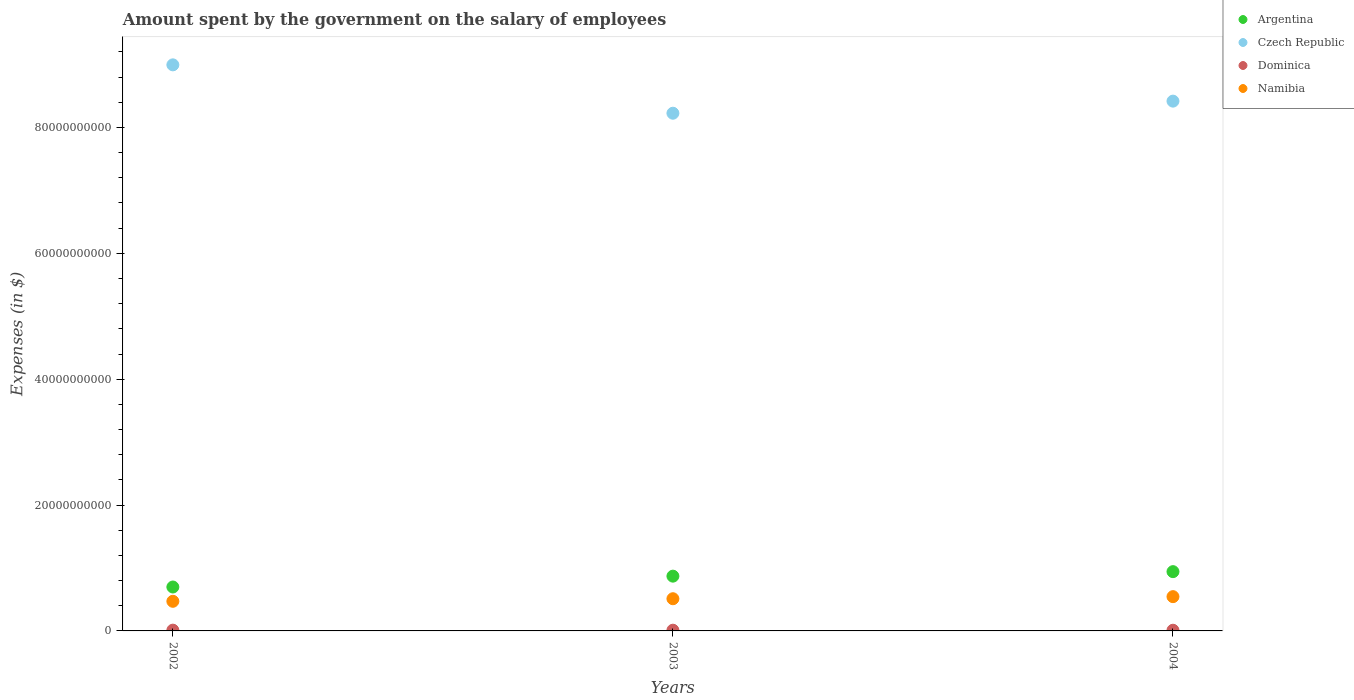How many different coloured dotlines are there?
Offer a terse response. 4. Is the number of dotlines equal to the number of legend labels?
Give a very brief answer. Yes. What is the amount spent on the salary of employees by the government in Namibia in 2002?
Make the answer very short. 4.71e+09. Across all years, what is the maximum amount spent on the salary of employees by the government in Czech Republic?
Your answer should be very brief. 9.00e+1. Across all years, what is the minimum amount spent on the salary of employees by the government in Namibia?
Offer a terse response. 4.71e+09. What is the total amount spent on the salary of employees by the government in Dominica in the graph?
Your answer should be very brief. 3.49e+08. What is the difference between the amount spent on the salary of employees by the government in Argentina in 2002 and that in 2003?
Your answer should be very brief. -1.72e+09. What is the difference between the amount spent on the salary of employees by the government in Czech Republic in 2002 and the amount spent on the salary of employees by the government in Namibia in 2003?
Your answer should be very brief. 8.48e+1. What is the average amount spent on the salary of employees by the government in Argentina per year?
Provide a succinct answer. 8.37e+09. In the year 2004, what is the difference between the amount spent on the salary of employees by the government in Dominica and amount spent on the salary of employees by the government in Czech Republic?
Offer a very short reply. -8.41e+1. What is the ratio of the amount spent on the salary of employees by the government in Czech Republic in 2002 to that in 2004?
Offer a terse response. 1.07. Is the difference between the amount spent on the salary of employees by the government in Dominica in 2002 and 2004 greater than the difference between the amount spent on the salary of employees by the government in Czech Republic in 2002 and 2004?
Provide a short and direct response. No. What is the difference between the highest and the second highest amount spent on the salary of employees by the government in Dominica?
Offer a very short reply. 8.30e+06. What is the difference between the highest and the lowest amount spent on the salary of employees by the government in Dominica?
Your response must be concise. 1.46e+07. In how many years, is the amount spent on the salary of employees by the government in Namibia greater than the average amount spent on the salary of employees by the government in Namibia taken over all years?
Your answer should be compact. 2. Is the sum of the amount spent on the salary of employees by the government in Czech Republic in 2002 and 2004 greater than the maximum amount spent on the salary of employees by the government in Argentina across all years?
Your answer should be very brief. Yes. Is the amount spent on the salary of employees by the government in Dominica strictly greater than the amount spent on the salary of employees by the government in Czech Republic over the years?
Your response must be concise. No. What is the difference between two consecutive major ticks on the Y-axis?
Give a very brief answer. 2.00e+1. How many legend labels are there?
Your answer should be compact. 4. What is the title of the graph?
Your answer should be very brief. Amount spent by the government on the salary of employees. What is the label or title of the Y-axis?
Offer a terse response. Expenses (in $). What is the Expenses (in $) in Argentina in 2002?
Offer a very short reply. 6.98e+09. What is the Expenses (in $) of Czech Republic in 2002?
Provide a succinct answer. 9.00e+1. What is the Expenses (in $) of Dominica in 2002?
Keep it short and to the point. 1.24e+08. What is the Expenses (in $) of Namibia in 2002?
Provide a short and direct response. 4.71e+09. What is the Expenses (in $) of Argentina in 2003?
Offer a terse response. 8.70e+09. What is the Expenses (in $) in Czech Republic in 2003?
Ensure brevity in your answer.  8.23e+1. What is the Expenses (in $) in Dominica in 2003?
Offer a terse response. 1.16e+08. What is the Expenses (in $) of Namibia in 2003?
Offer a terse response. 5.12e+09. What is the Expenses (in $) in Argentina in 2004?
Offer a terse response. 9.42e+09. What is the Expenses (in $) in Czech Republic in 2004?
Provide a short and direct response. 8.42e+1. What is the Expenses (in $) of Dominica in 2004?
Provide a succinct answer. 1.09e+08. What is the Expenses (in $) in Namibia in 2004?
Provide a short and direct response. 5.45e+09. Across all years, what is the maximum Expenses (in $) of Argentina?
Ensure brevity in your answer.  9.42e+09. Across all years, what is the maximum Expenses (in $) in Czech Republic?
Provide a short and direct response. 9.00e+1. Across all years, what is the maximum Expenses (in $) in Dominica?
Provide a short and direct response. 1.24e+08. Across all years, what is the maximum Expenses (in $) in Namibia?
Provide a succinct answer. 5.45e+09. Across all years, what is the minimum Expenses (in $) of Argentina?
Offer a very short reply. 6.98e+09. Across all years, what is the minimum Expenses (in $) of Czech Republic?
Make the answer very short. 8.23e+1. Across all years, what is the minimum Expenses (in $) in Dominica?
Give a very brief answer. 1.09e+08. Across all years, what is the minimum Expenses (in $) in Namibia?
Provide a succinct answer. 4.71e+09. What is the total Expenses (in $) of Argentina in the graph?
Give a very brief answer. 2.51e+1. What is the total Expenses (in $) of Czech Republic in the graph?
Ensure brevity in your answer.  2.56e+11. What is the total Expenses (in $) of Dominica in the graph?
Offer a terse response. 3.49e+08. What is the total Expenses (in $) of Namibia in the graph?
Provide a short and direct response. 1.53e+1. What is the difference between the Expenses (in $) of Argentina in 2002 and that in 2003?
Provide a succinct answer. -1.72e+09. What is the difference between the Expenses (in $) of Czech Republic in 2002 and that in 2003?
Offer a very short reply. 7.69e+09. What is the difference between the Expenses (in $) of Dominica in 2002 and that in 2003?
Make the answer very short. 8.30e+06. What is the difference between the Expenses (in $) of Namibia in 2002 and that in 2003?
Offer a terse response. -4.10e+08. What is the difference between the Expenses (in $) of Argentina in 2002 and that in 2004?
Keep it short and to the point. -2.44e+09. What is the difference between the Expenses (in $) of Czech Republic in 2002 and that in 2004?
Your answer should be very brief. 5.77e+09. What is the difference between the Expenses (in $) in Dominica in 2002 and that in 2004?
Ensure brevity in your answer.  1.46e+07. What is the difference between the Expenses (in $) in Namibia in 2002 and that in 2004?
Make the answer very short. -7.39e+08. What is the difference between the Expenses (in $) of Argentina in 2003 and that in 2004?
Give a very brief answer. -7.17e+08. What is the difference between the Expenses (in $) in Czech Republic in 2003 and that in 2004?
Offer a terse response. -1.92e+09. What is the difference between the Expenses (in $) in Dominica in 2003 and that in 2004?
Give a very brief answer. 6.30e+06. What is the difference between the Expenses (in $) of Namibia in 2003 and that in 2004?
Your answer should be very brief. -3.29e+08. What is the difference between the Expenses (in $) of Argentina in 2002 and the Expenses (in $) of Czech Republic in 2003?
Your answer should be very brief. -7.53e+1. What is the difference between the Expenses (in $) of Argentina in 2002 and the Expenses (in $) of Dominica in 2003?
Your answer should be very brief. 6.86e+09. What is the difference between the Expenses (in $) in Argentina in 2002 and the Expenses (in $) in Namibia in 2003?
Offer a very short reply. 1.86e+09. What is the difference between the Expenses (in $) in Czech Republic in 2002 and the Expenses (in $) in Dominica in 2003?
Ensure brevity in your answer.  8.98e+1. What is the difference between the Expenses (in $) of Czech Republic in 2002 and the Expenses (in $) of Namibia in 2003?
Your answer should be compact. 8.48e+1. What is the difference between the Expenses (in $) in Dominica in 2002 and the Expenses (in $) in Namibia in 2003?
Make the answer very short. -4.99e+09. What is the difference between the Expenses (in $) in Argentina in 2002 and the Expenses (in $) in Czech Republic in 2004?
Give a very brief answer. -7.72e+1. What is the difference between the Expenses (in $) in Argentina in 2002 and the Expenses (in $) in Dominica in 2004?
Your response must be concise. 6.87e+09. What is the difference between the Expenses (in $) of Argentina in 2002 and the Expenses (in $) of Namibia in 2004?
Your response must be concise. 1.53e+09. What is the difference between the Expenses (in $) in Czech Republic in 2002 and the Expenses (in $) in Dominica in 2004?
Offer a terse response. 8.98e+1. What is the difference between the Expenses (in $) of Czech Republic in 2002 and the Expenses (in $) of Namibia in 2004?
Provide a succinct answer. 8.45e+1. What is the difference between the Expenses (in $) of Dominica in 2002 and the Expenses (in $) of Namibia in 2004?
Keep it short and to the point. -5.32e+09. What is the difference between the Expenses (in $) of Argentina in 2003 and the Expenses (in $) of Czech Republic in 2004?
Offer a very short reply. -7.55e+1. What is the difference between the Expenses (in $) of Argentina in 2003 and the Expenses (in $) of Dominica in 2004?
Provide a short and direct response. 8.59e+09. What is the difference between the Expenses (in $) in Argentina in 2003 and the Expenses (in $) in Namibia in 2004?
Give a very brief answer. 3.26e+09. What is the difference between the Expenses (in $) in Czech Republic in 2003 and the Expenses (in $) in Dominica in 2004?
Your answer should be compact. 8.22e+1. What is the difference between the Expenses (in $) of Czech Republic in 2003 and the Expenses (in $) of Namibia in 2004?
Provide a succinct answer. 7.68e+1. What is the difference between the Expenses (in $) of Dominica in 2003 and the Expenses (in $) of Namibia in 2004?
Your answer should be compact. -5.33e+09. What is the average Expenses (in $) of Argentina per year?
Offer a terse response. 8.37e+09. What is the average Expenses (in $) in Czech Republic per year?
Offer a very short reply. 8.55e+1. What is the average Expenses (in $) of Dominica per year?
Your response must be concise. 1.16e+08. What is the average Expenses (in $) of Namibia per year?
Offer a terse response. 5.09e+09. In the year 2002, what is the difference between the Expenses (in $) of Argentina and Expenses (in $) of Czech Republic?
Offer a terse response. -8.30e+1. In the year 2002, what is the difference between the Expenses (in $) of Argentina and Expenses (in $) of Dominica?
Offer a terse response. 6.85e+09. In the year 2002, what is the difference between the Expenses (in $) in Argentina and Expenses (in $) in Namibia?
Offer a terse response. 2.27e+09. In the year 2002, what is the difference between the Expenses (in $) of Czech Republic and Expenses (in $) of Dominica?
Offer a very short reply. 8.98e+1. In the year 2002, what is the difference between the Expenses (in $) of Czech Republic and Expenses (in $) of Namibia?
Your answer should be very brief. 8.52e+1. In the year 2002, what is the difference between the Expenses (in $) in Dominica and Expenses (in $) in Namibia?
Your answer should be very brief. -4.58e+09. In the year 2003, what is the difference between the Expenses (in $) in Argentina and Expenses (in $) in Czech Republic?
Ensure brevity in your answer.  -7.36e+1. In the year 2003, what is the difference between the Expenses (in $) of Argentina and Expenses (in $) of Dominica?
Your answer should be very brief. 8.59e+09. In the year 2003, what is the difference between the Expenses (in $) in Argentina and Expenses (in $) in Namibia?
Make the answer very short. 3.59e+09. In the year 2003, what is the difference between the Expenses (in $) in Czech Republic and Expenses (in $) in Dominica?
Make the answer very short. 8.21e+1. In the year 2003, what is the difference between the Expenses (in $) of Czech Republic and Expenses (in $) of Namibia?
Give a very brief answer. 7.71e+1. In the year 2003, what is the difference between the Expenses (in $) in Dominica and Expenses (in $) in Namibia?
Your response must be concise. -5.00e+09. In the year 2004, what is the difference between the Expenses (in $) of Argentina and Expenses (in $) of Czech Republic?
Keep it short and to the point. -7.48e+1. In the year 2004, what is the difference between the Expenses (in $) of Argentina and Expenses (in $) of Dominica?
Offer a very short reply. 9.31e+09. In the year 2004, what is the difference between the Expenses (in $) in Argentina and Expenses (in $) in Namibia?
Ensure brevity in your answer.  3.97e+09. In the year 2004, what is the difference between the Expenses (in $) of Czech Republic and Expenses (in $) of Dominica?
Provide a short and direct response. 8.41e+1. In the year 2004, what is the difference between the Expenses (in $) in Czech Republic and Expenses (in $) in Namibia?
Ensure brevity in your answer.  7.87e+1. In the year 2004, what is the difference between the Expenses (in $) of Dominica and Expenses (in $) of Namibia?
Your answer should be very brief. -5.34e+09. What is the ratio of the Expenses (in $) of Argentina in 2002 to that in 2003?
Make the answer very short. 0.8. What is the ratio of the Expenses (in $) of Czech Republic in 2002 to that in 2003?
Provide a short and direct response. 1.09. What is the ratio of the Expenses (in $) of Dominica in 2002 to that in 2003?
Make the answer very short. 1.07. What is the ratio of the Expenses (in $) of Namibia in 2002 to that in 2003?
Provide a succinct answer. 0.92. What is the ratio of the Expenses (in $) of Argentina in 2002 to that in 2004?
Give a very brief answer. 0.74. What is the ratio of the Expenses (in $) of Czech Republic in 2002 to that in 2004?
Offer a very short reply. 1.07. What is the ratio of the Expenses (in $) of Dominica in 2002 to that in 2004?
Keep it short and to the point. 1.13. What is the ratio of the Expenses (in $) of Namibia in 2002 to that in 2004?
Offer a very short reply. 0.86. What is the ratio of the Expenses (in $) in Argentina in 2003 to that in 2004?
Ensure brevity in your answer.  0.92. What is the ratio of the Expenses (in $) in Czech Republic in 2003 to that in 2004?
Make the answer very short. 0.98. What is the ratio of the Expenses (in $) in Dominica in 2003 to that in 2004?
Offer a very short reply. 1.06. What is the ratio of the Expenses (in $) of Namibia in 2003 to that in 2004?
Ensure brevity in your answer.  0.94. What is the difference between the highest and the second highest Expenses (in $) in Argentina?
Offer a very short reply. 7.17e+08. What is the difference between the highest and the second highest Expenses (in $) of Czech Republic?
Your response must be concise. 5.77e+09. What is the difference between the highest and the second highest Expenses (in $) in Dominica?
Offer a terse response. 8.30e+06. What is the difference between the highest and the second highest Expenses (in $) in Namibia?
Ensure brevity in your answer.  3.29e+08. What is the difference between the highest and the lowest Expenses (in $) in Argentina?
Your answer should be compact. 2.44e+09. What is the difference between the highest and the lowest Expenses (in $) in Czech Republic?
Keep it short and to the point. 7.69e+09. What is the difference between the highest and the lowest Expenses (in $) in Dominica?
Make the answer very short. 1.46e+07. What is the difference between the highest and the lowest Expenses (in $) in Namibia?
Offer a very short reply. 7.39e+08. 